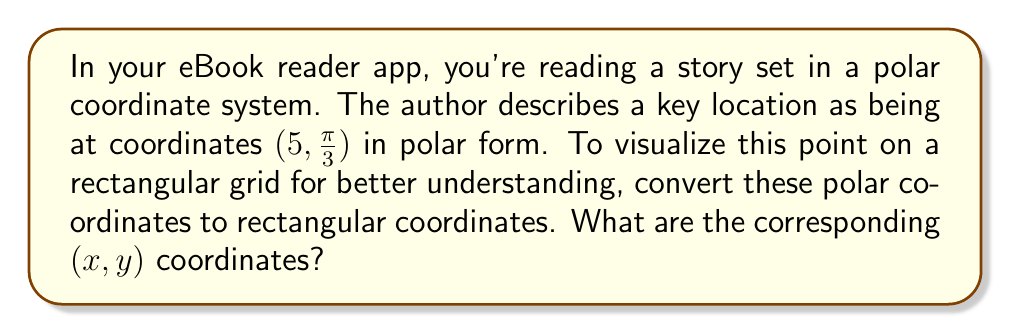Give your solution to this math problem. To convert polar coordinates $(r, \theta)$ to rectangular coordinates $(x, y)$, we use these formulas:

$$x = r \cos(\theta)$$
$$y = r \sin(\theta)$$

Given polar coordinates: $(r, \theta) = (5, \frac{\pi}{3})$

Step 1: Calculate $x$
$$x = r \cos(\theta) = 5 \cos(\frac{\pi}{3})$$

$\cos(\frac{\pi}{3}) = \frac{1}{2}$, so:
$$x = 5 \cdot \frac{1}{2} = \frac{5}{2} = 2.5$$

Step 2: Calculate $y$
$$y = r \sin(\theta) = 5 \sin(\frac{\pi}{3})$$

$\sin(\frac{\pi}{3}) = \frac{\sqrt{3}}{2}$, so:
$$y = 5 \cdot \frac{\sqrt{3}}{2} = \frac{5\sqrt{3}}{2} \approx 4.33$$

Therefore, the rectangular coordinates are approximately $(2.5, 4.33)$.

[asy]
unitsize(1cm);
draw((-1,0)--(6,0),arrow=Arrow(TeXHead));
draw((0,-1)--(0,6),arrow=Arrow(TeXHead));
dot((2.5,4.33),red);
label("(2.5, 4.33)",(2.5,4.33),NE);
draw((0,0)--(2.5,4.33),dashed);
[/asy]
Answer: $(2.5, 4.33)$ 